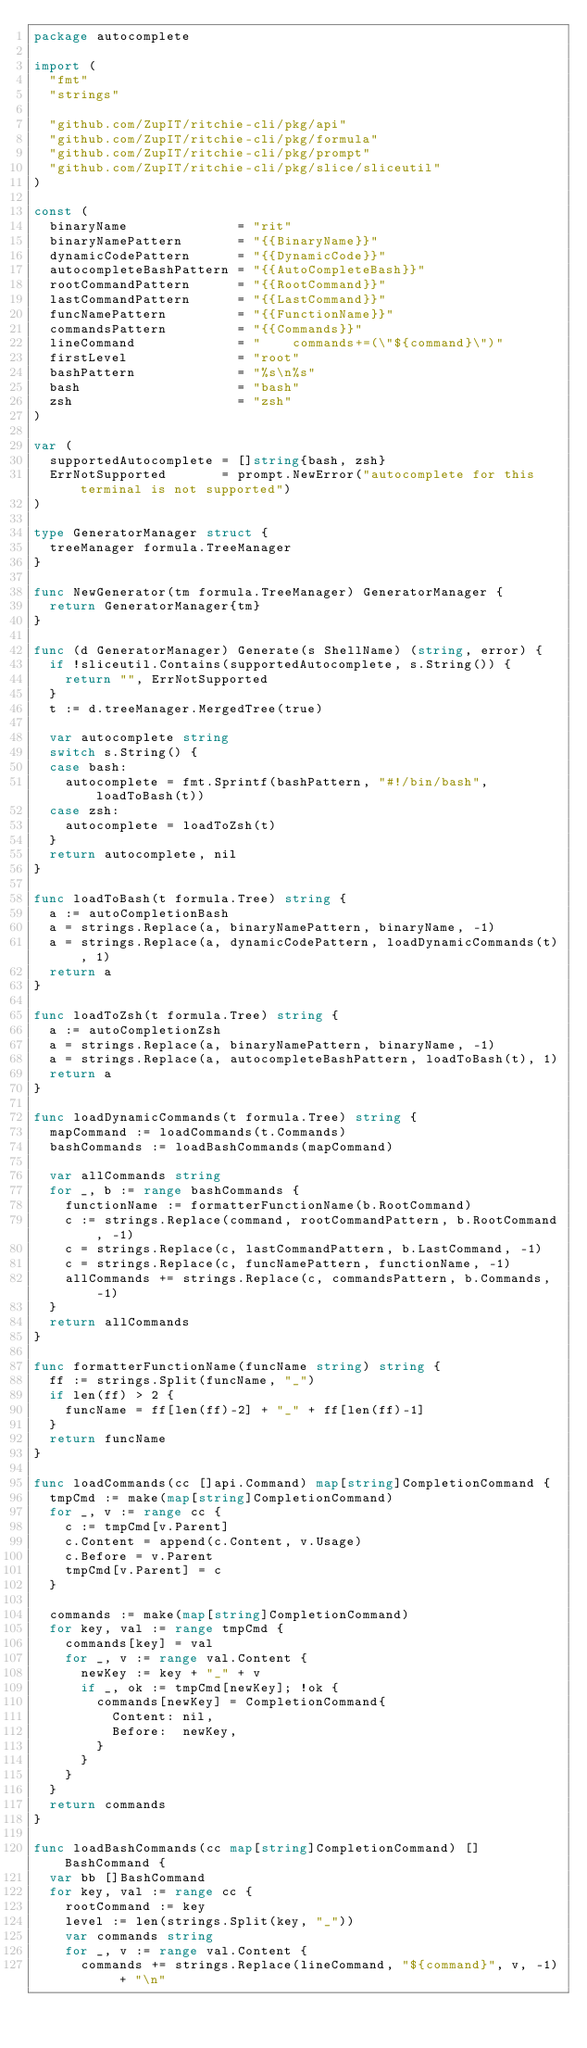<code> <loc_0><loc_0><loc_500><loc_500><_Go_>package autocomplete

import (
	"fmt"
	"strings"

	"github.com/ZupIT/ritchie-cli/pkg/api"
	"github.com/ZupIT/ritchie-cli/pkg/formula"
	"github.com/ZupIT/ritchie-cli/pkg/prompt"
	"github.com/ZupIT/ritchie-cli/pkg/slice/sliceutil"
)

const (
	binaryName              = "rit"
	binaryNamePattern       = "{{BinaryName}}"
	dynamicCodePattern      = "{{DynamicCode}}"
	autocompleteBashPattern = "{{AutoCompleteBash}}"
	rootCommandPattern      = "{{RootCommand}}"
	lastCommandPattern      = "{{LastCommand}}"
	funcNamePattern         = "{{FunctionName}}"
	commandsPattern         = "{{Commands}}"
	lineCommand             = "    commands+=(\"${command}\")"
	firstLevel              = "root"
	bashPattern             = "%s\n%s"
	bash                    = "bash"
	zsh                     = "zsh"
)

var (
	supportedAutocomplete = []string{bash, zsh}
	ErrNotSupported       = prompt.NewError("autocomplete for this terminal is not supported")
)

type GeneratorManager struct {
	treeManager formula.TreeManager
}

func NewGenerator(tm formula.TreeManager) GeneratorManager {
	return GeneratorManager{tm}
}

func (d GeneratorManager) Generate(s ShellName) (string, error) {
	if !sliceutil.Contains(supportedAutocomplete, s.String()) {
		return "", ErrNotSupported
	}
	t := d.treeManager.MergedTree(true)

	var autocomplete string
	switch s.String() {
	case bash:
		autocomplete = fmt.Sprintf(bashPattern, "#!/bin/bash", loadToBash(t))
	case zsh:
		autocomplete = loadToZsh(t)
	}
	return autocomplete, nil
}

func loadToBash(t formula.Tree) string {
	a := autoCompletionBash
	a = strings.Replace(a, binaryNamePattern, binaryName, -1)
	a = strings.Replace(a, dynamicCodePattern, loadDynamicCommands(t), 1)
	return a
}

func loadToZsh(t formula.Tree) string {
	a := autoCompletionZsh
	a = strings.Replace(a, binaryNamePattern, binaryName, -1)
	a = strings.Replace(a, autocompleteBashPattern, loadToBash(t), 1)
	return a
}

func loadDynamicCommands(t formula.Tree) string {
	mapCommand := loadCommands(t.Commands)
	bashCommands := loadBashCommands(mapCommand)

	var allCommands string
	for _, b := range bashCommands {
		functionName := formatterFunctionName(b.RootCommand)
		c := strings.Replace(command, rootCommandPattern, b.RootCommand, -1)
		c = strings.Replace(c, lastCommandPattern, b.LastCommand, -1)
		c = strings.Replace(c, funcNamePattern, functionName, -1)
		allCommands += strings.Replace(c, commandsPattern, b.Commands, -1)
	}
	return allCommands
}

func formatterFunctionName(funcName string) string {
	ff := strings.Split(funcName, "_")
	if len(ff) > 2 {
		funcName = ff[len(ff)-2] + "_" + ff[len(ff)-1]
	}
	return funcName
}

func loadCommands(cc []api.Command) map[string]CompletionCommand {
	tmpCmd := make(map[string]CompletionCommand)
	for _, v := range cc {
		c := tmpCmd[v.Parent]
		c.Content = append(c.Content, v.Usage)
		c.Before = v.Parent
		tmpCmd[v.Parent] = c
	}

	commands := make(map[string]CompletionCommand)
	for key, val := range tmpCmd {
		commands[key] = val
		for _, v := range val.Content {
			newKey := key + "_" + v
			if _, ok := tmpCmd[newKey]; !ok {
				commands[newKey] = CompletionCommand{
					Content: nil,
					Before:  newKey,
				}
			}
		}
	}
	return commands
}

func loadBashCommands(cc map[string]CompletionCommand) []BashCommand {
	var bb []BashCommand
	for key, val := range cc {
		rootCommand := key
		level := len(strings.Split(key, "_"))
		var commands string
		for _, v := range val.Content {
			commands += strings.Replace(lineCommand, "${command}", v, -1) + "\n"</code> 